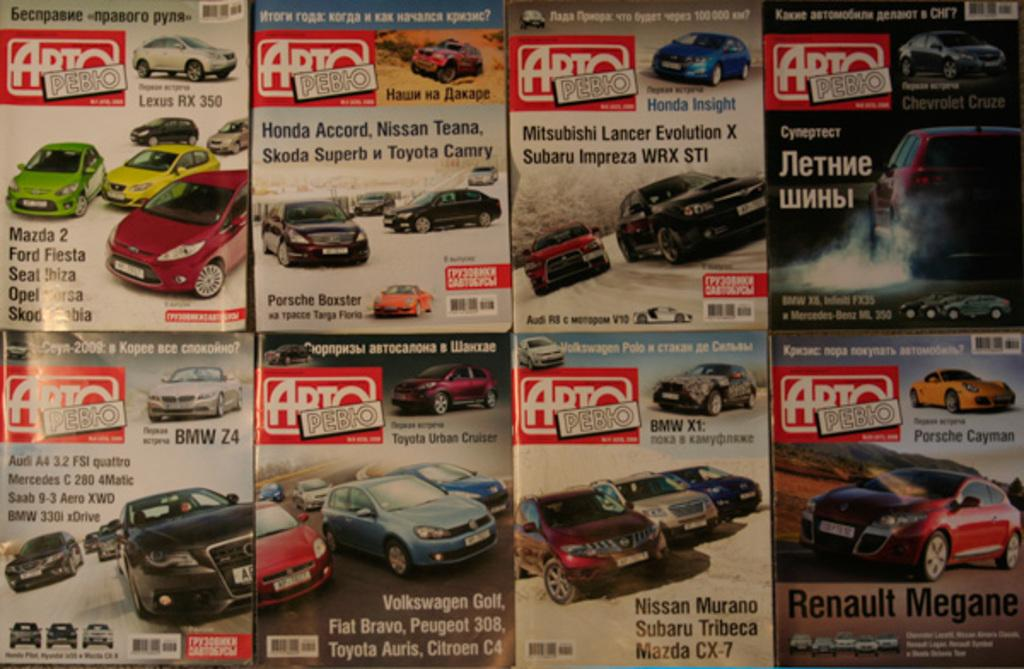What can be seen on the posters in the image? The posters have depictions of cars. Are there any words or letters on the posters? Yes, there is text on the posters. What color is the tongue on the poster? There is no tongue present on the posters in the image. Is the poster a work of fiction or non-fiction? The provided facts do not indicate whether the poster is fiction or non-fiction. 